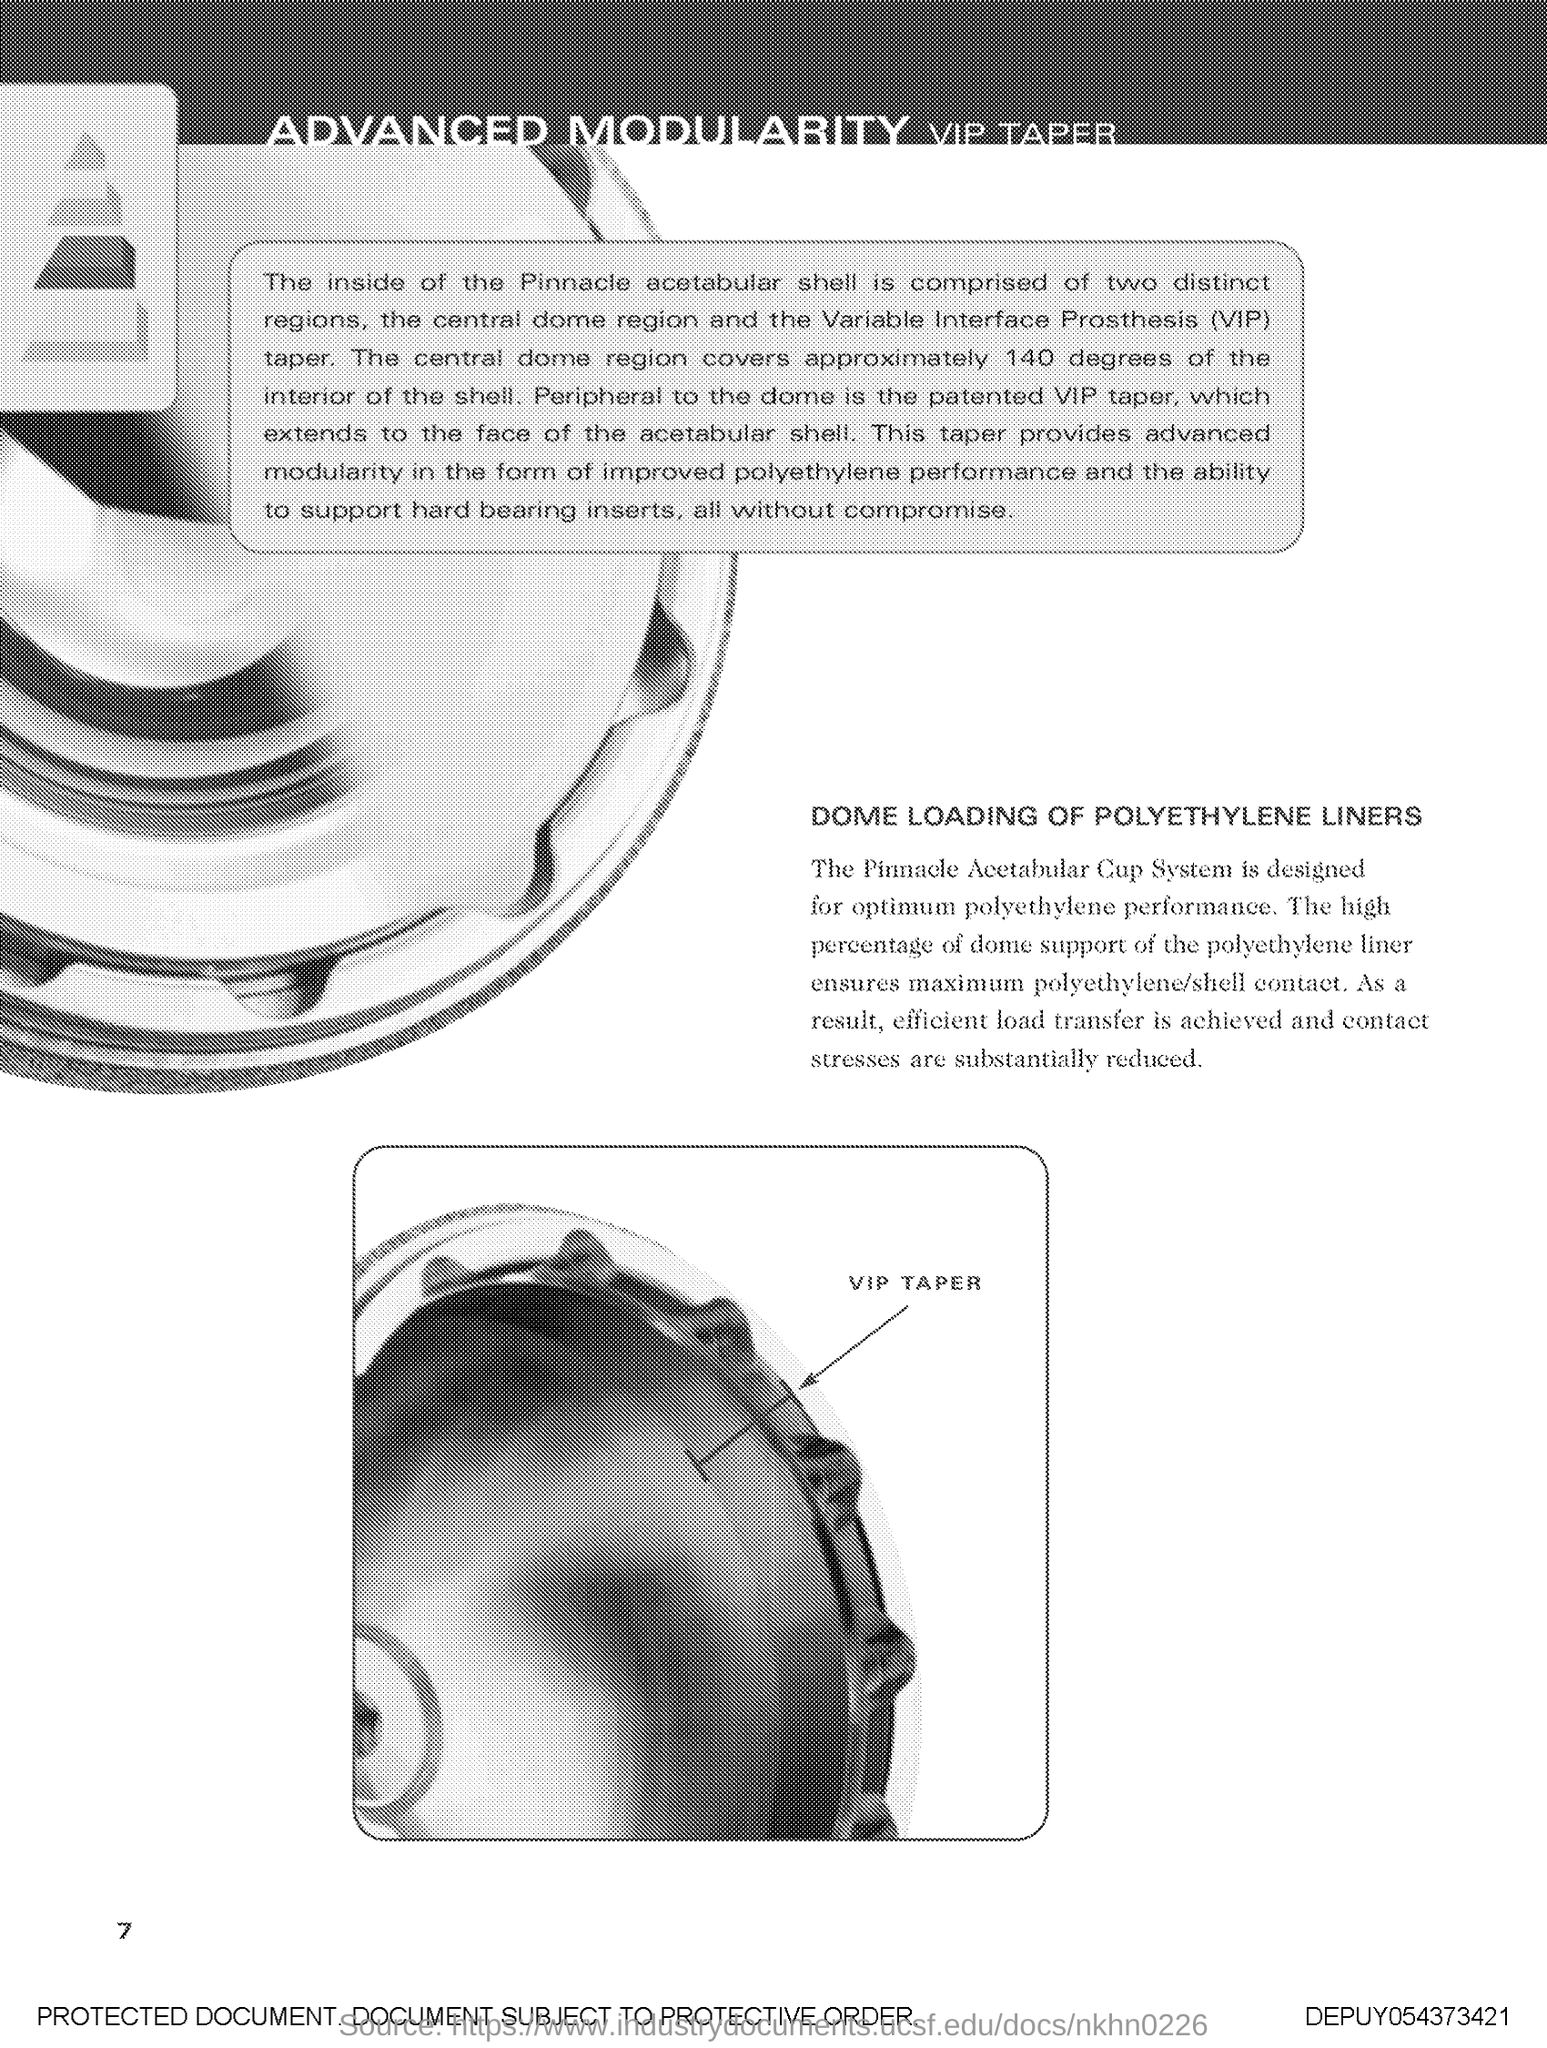What is the fullform of VIP?
Provide a succinct answer. Variable Interface Prosthesis. Which system is designed for optimum polyethylene performance?
Keep it short and to the point. The Pinnacle Acetabular Cup System. What is the page no mentioned in this document?
Your answer should be very brief. 7. What are the two distinct regions inside the Pinnacle acetabular shell?
Give a very brief answer. The central dome region and the variable interface prosthesis (vip) taper. 